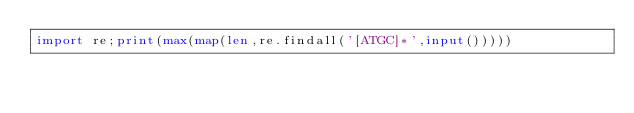<code> <loc_0><loc_0><loc_500><loc_500><_Python_>import re;print(max(map(len,re.findall('[ATGC]*',input()))))</code> 